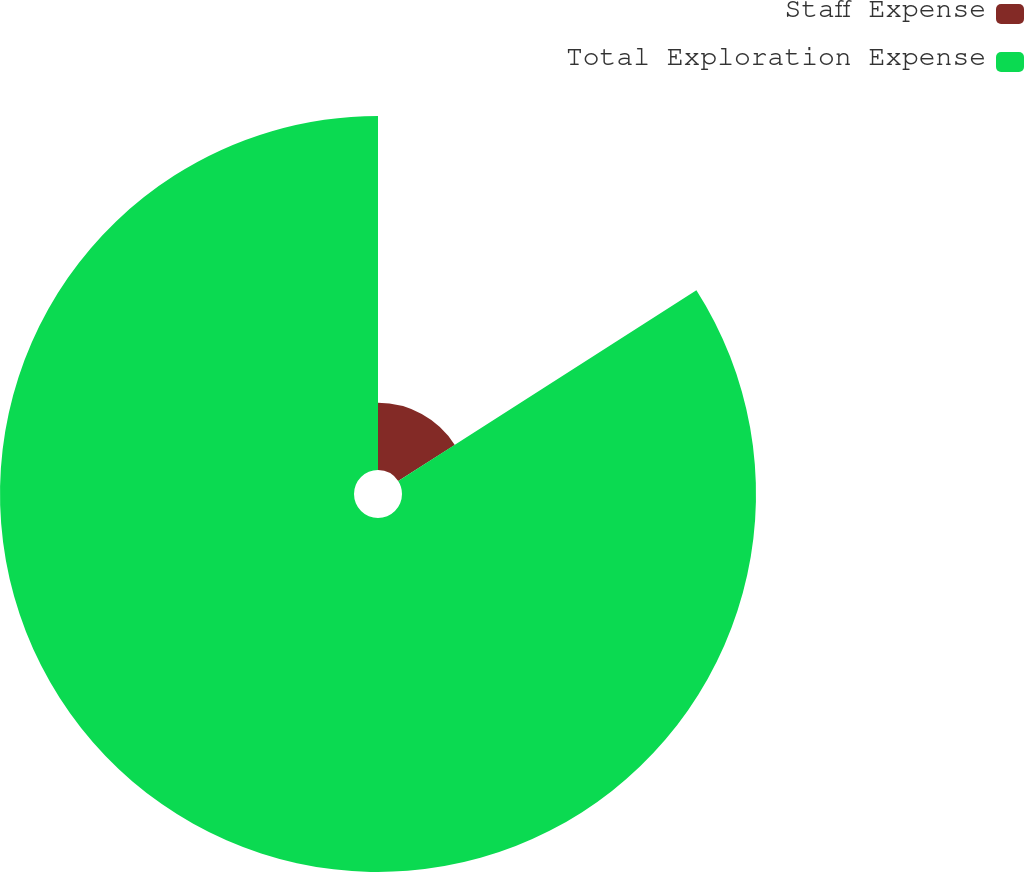Convert chart. <chart><loc_0><loc_0><loc_500><loc_500><pie_chart><fcel>Staff Expense<fcel>Total Exploration Expense<nl><fcel>15.94%<fcel>84.06%<nl></chart> 